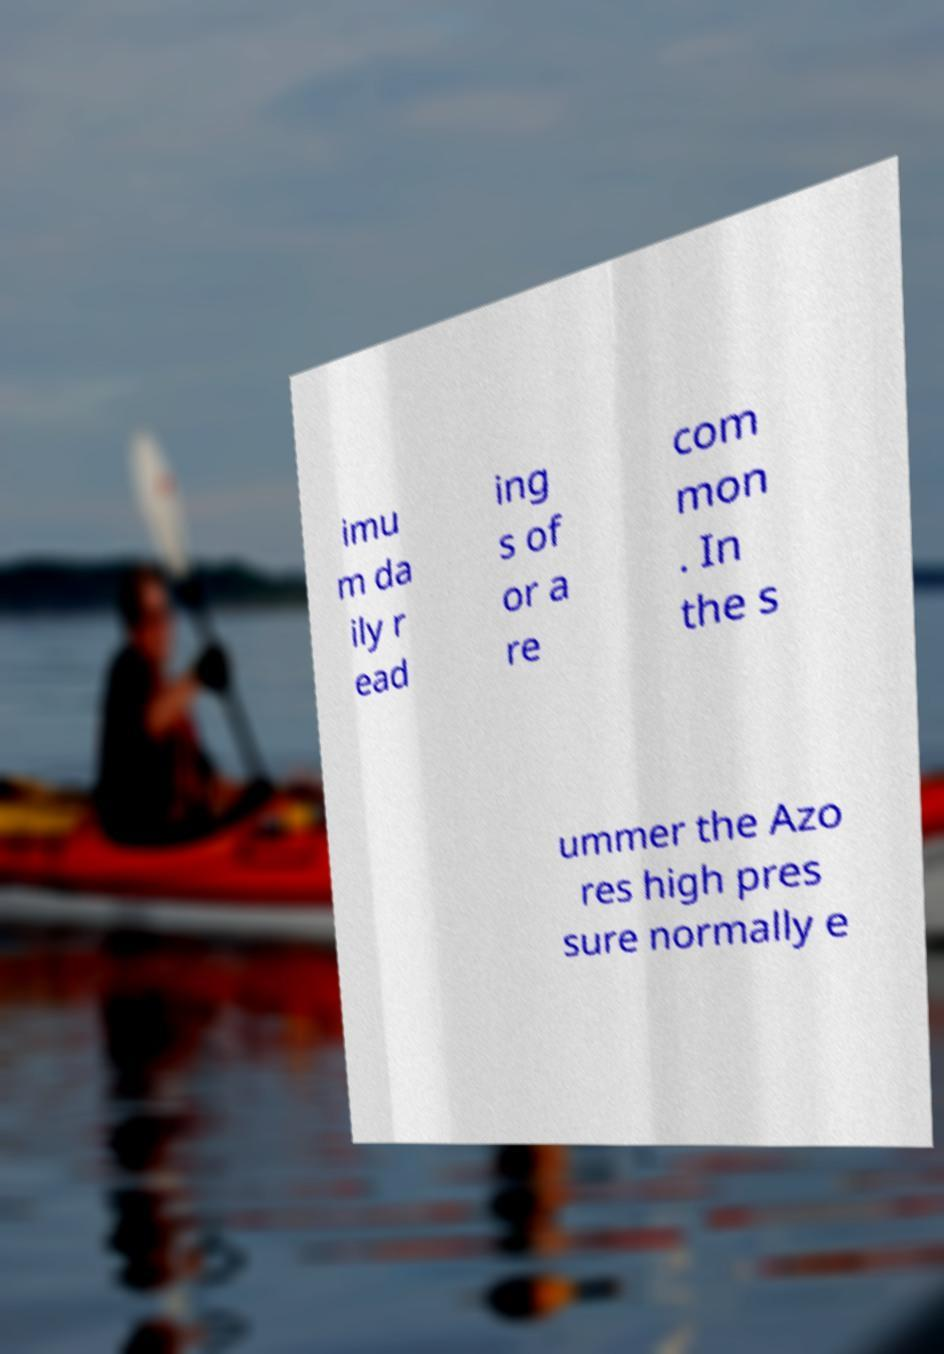Could you assist in decoding the text presented in this image and type it out clearly? imu m da ily r ead ing s of or a re com mon . In the s ummer the Azo res high pres sure normally e 